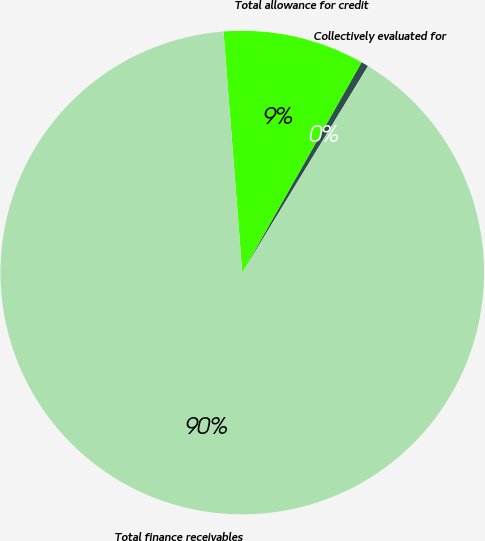<chart> <loc_0><loc_0><loc_500><loc_500><pie_chart><fcel>Collectively evaluated for<fcel>Total allowance for credit<fcel>Total finance receivables<nl><fcel>0.49%<fcel>9.45%<fcel>90.06%<nl></chart> 